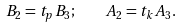<formula> <loc_0><loc_0><loc_500><loc_500>B _ { 2 } = t _ { p } B _ { 3 } ; \quad A _ { 2 } = t _ { k } A _ { 3 } .</formula> 